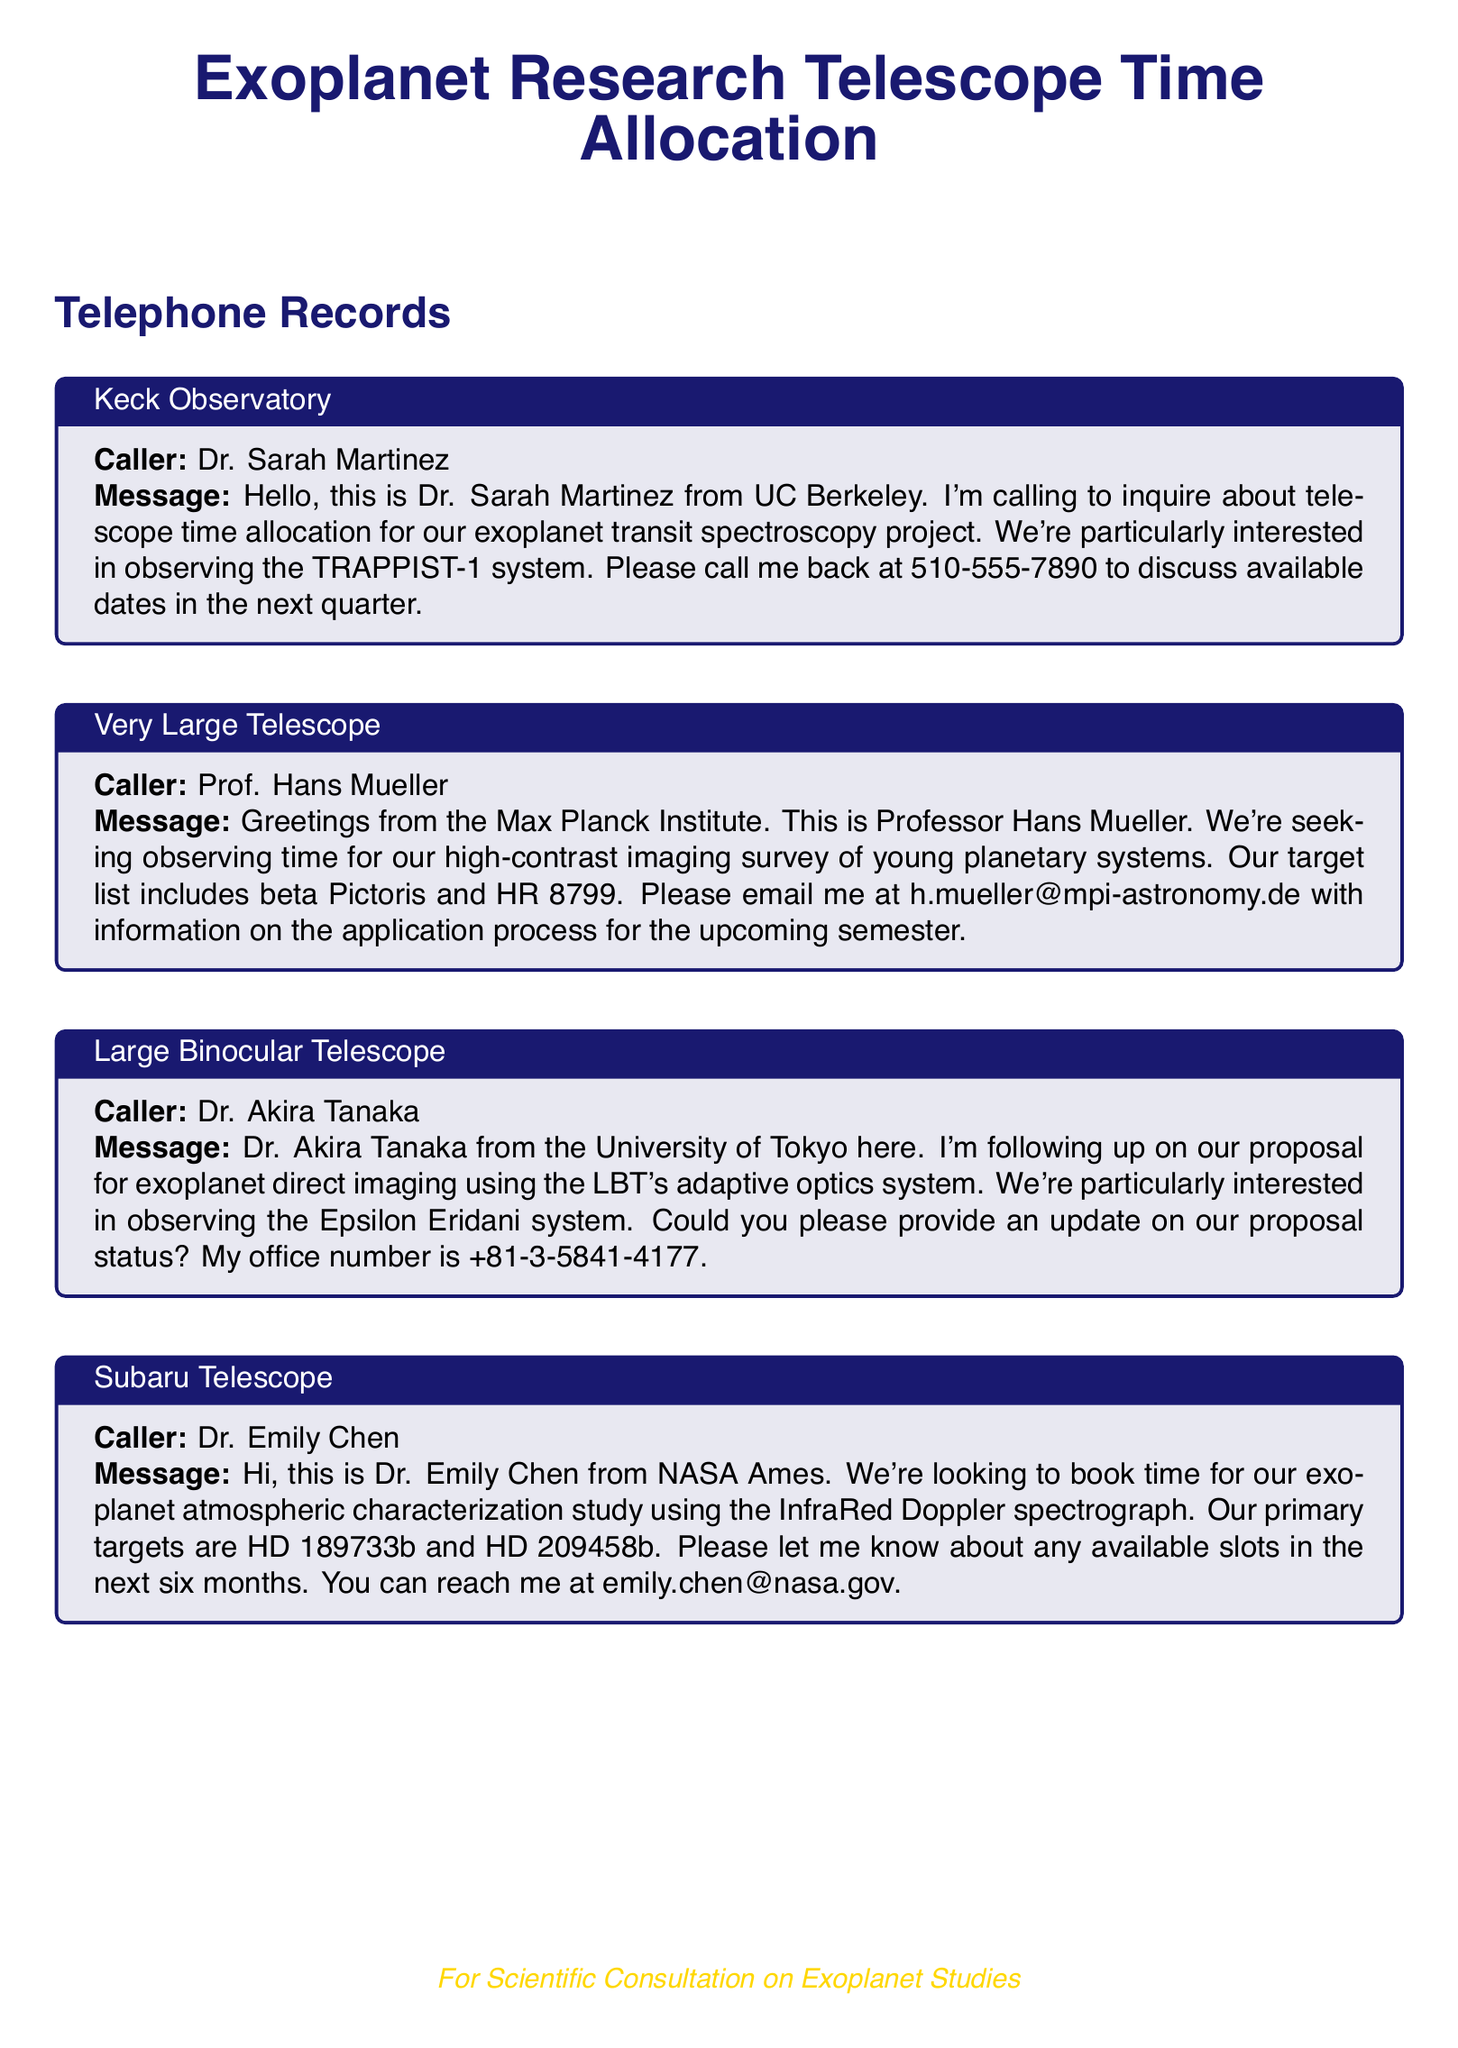What is Dr. Sarah Martinez's affiliation? Dr. Sarah Martinez is from UC Berkeley as mentioned in her message.
Answer: UC Berkeley Which exoplanet system is Dr. Sarah Martinez interested in? Dr. Sarah Martinez is interested in the TRAPPIST-1 system for her project.
Answer: TRAPPIST-1 Who is seeking observing time for a high-contrast imaging survey? The caller looking for observing time for high-contrast imaging is Professor Hans Mueller.
Answer: Professor Hans Mueller What is the primary target of Dr. Emily Chen's study? Dr. Emily Chen's primary targets for her study are HD 189733b and HD 209458b.
Answer: HD 189733b and HD 209458b What type of telescope is Dr. Akira Tanaka following up with? Dr. Akira Tanaka is following up with the Large Binocular Telescope.
Answer: Large Binocular Telescope Which observatory is mentioned in connection with Young planetary systems? The Very Large Telescope is mentioned in connection with young planetary systems.
Answer: Very Large Telescope What is Dr. Emily Chen's email address? Dr. Emily Chen provides her email address as emily.chen@nasa.gov.
Answer: emily.chen@nasa.gov How many months does Dr. Emily Chen inquire about available slots? Dr. Emily Chen is inquiring about available slots in the next six months.
Answer: six months What type of exoplanet study is Dr. Emily Chen conducting? Dr. Emily Chen is conducting an atmospheric characterization study.
Answer: atmospheric characterization study 